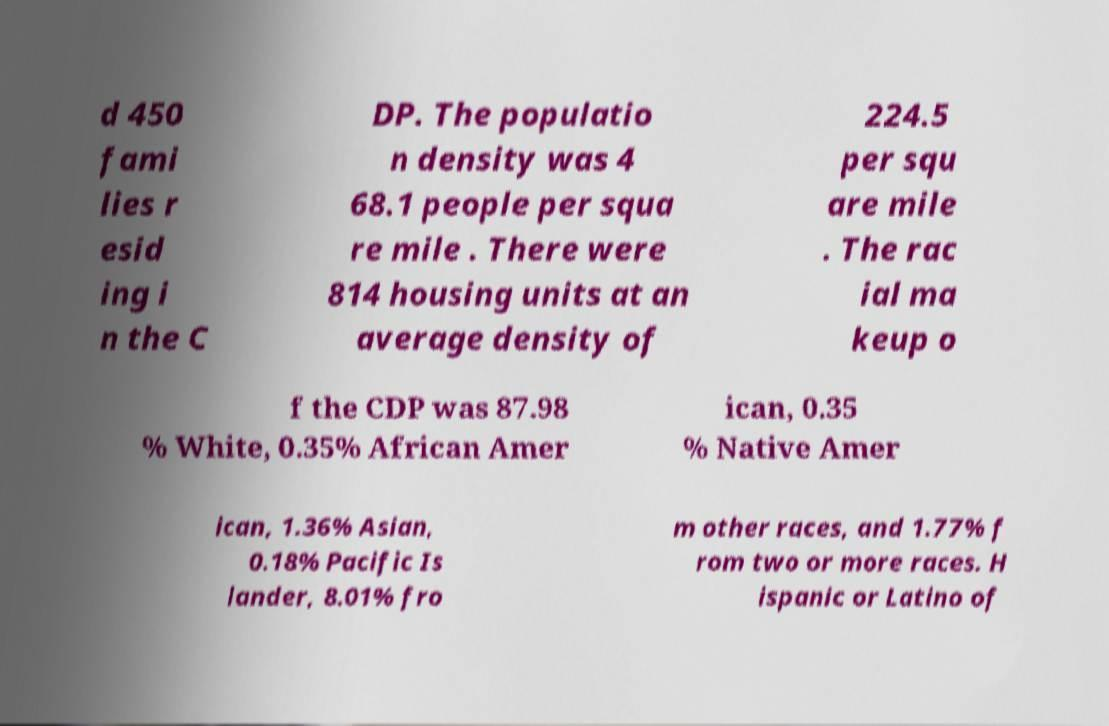Can you read and provide the text displayed in the image?This photo seems to have some interesting text. Can you extract and type it out for me? d 450 fami lies r esid ing i n the C DP. The populatio n density was 4 68.1 people per squa re mile . There were 814 housing units at an average density of 224.5 per squ are mile . The rac ial ma keup o f the CDP was 87.98 % White, 0.35% African Amer ican, 0.35 % Native Amer ican, 1.36% Asian, 0.18% Pacific Is lander, 8.01% fro m other races, and 1.77% f rom two or more races. H ispanic or Latino of 